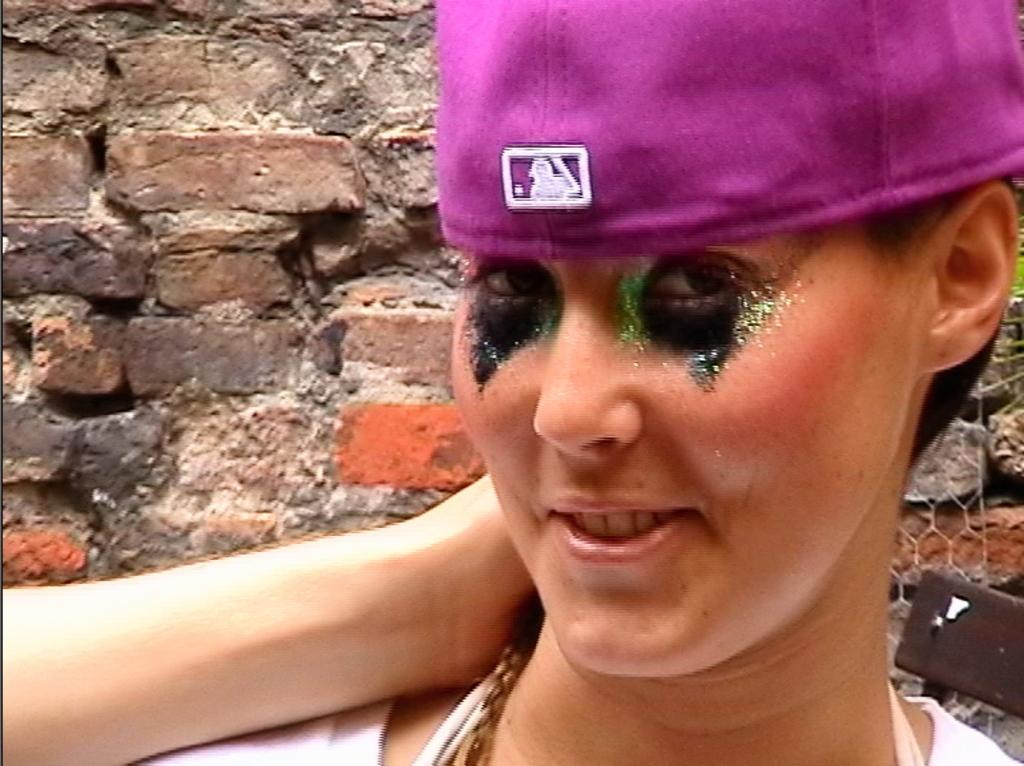Who is present in the image? There is a woman in the image. What is the woman's facial expression? The woman is smiling. What can be seen in the background of the image? There is a brick wall in the background of the image. What type of spoon is the woman holding in the image? There is no spoon present in the image. How many balls can be seen in the image? There are no balls present in the image. 